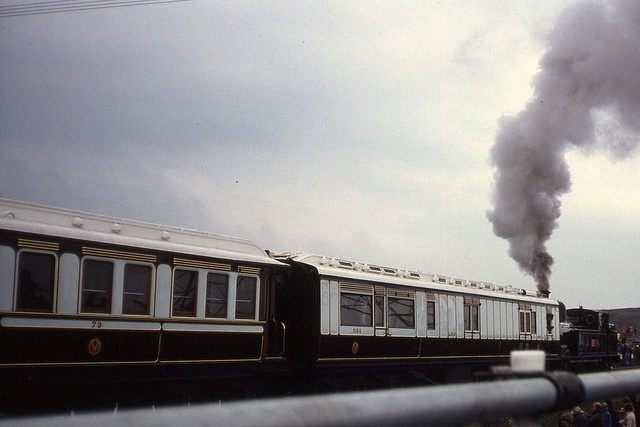Describe the objects in this image and their specific colors. I can see train in gray, black, darkgray, and lightgray tones, people in gray and black tones, and people in gray, black, and darkgray tones in this image. 